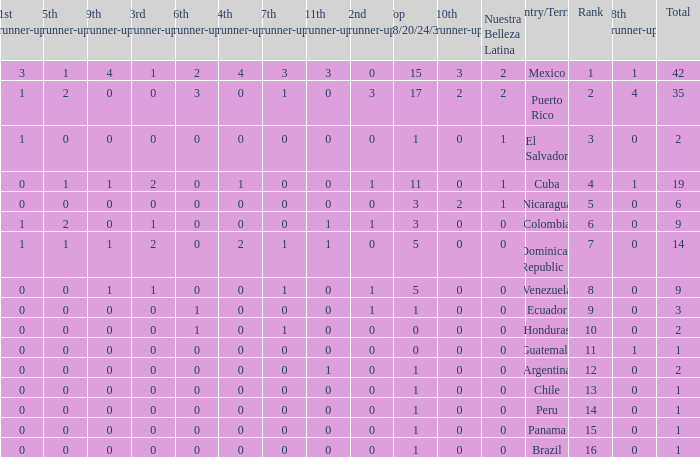What is the 9th runner-up with a top 18/20/24/30 greater than 17 and a 5th runner-up of 2? None. 